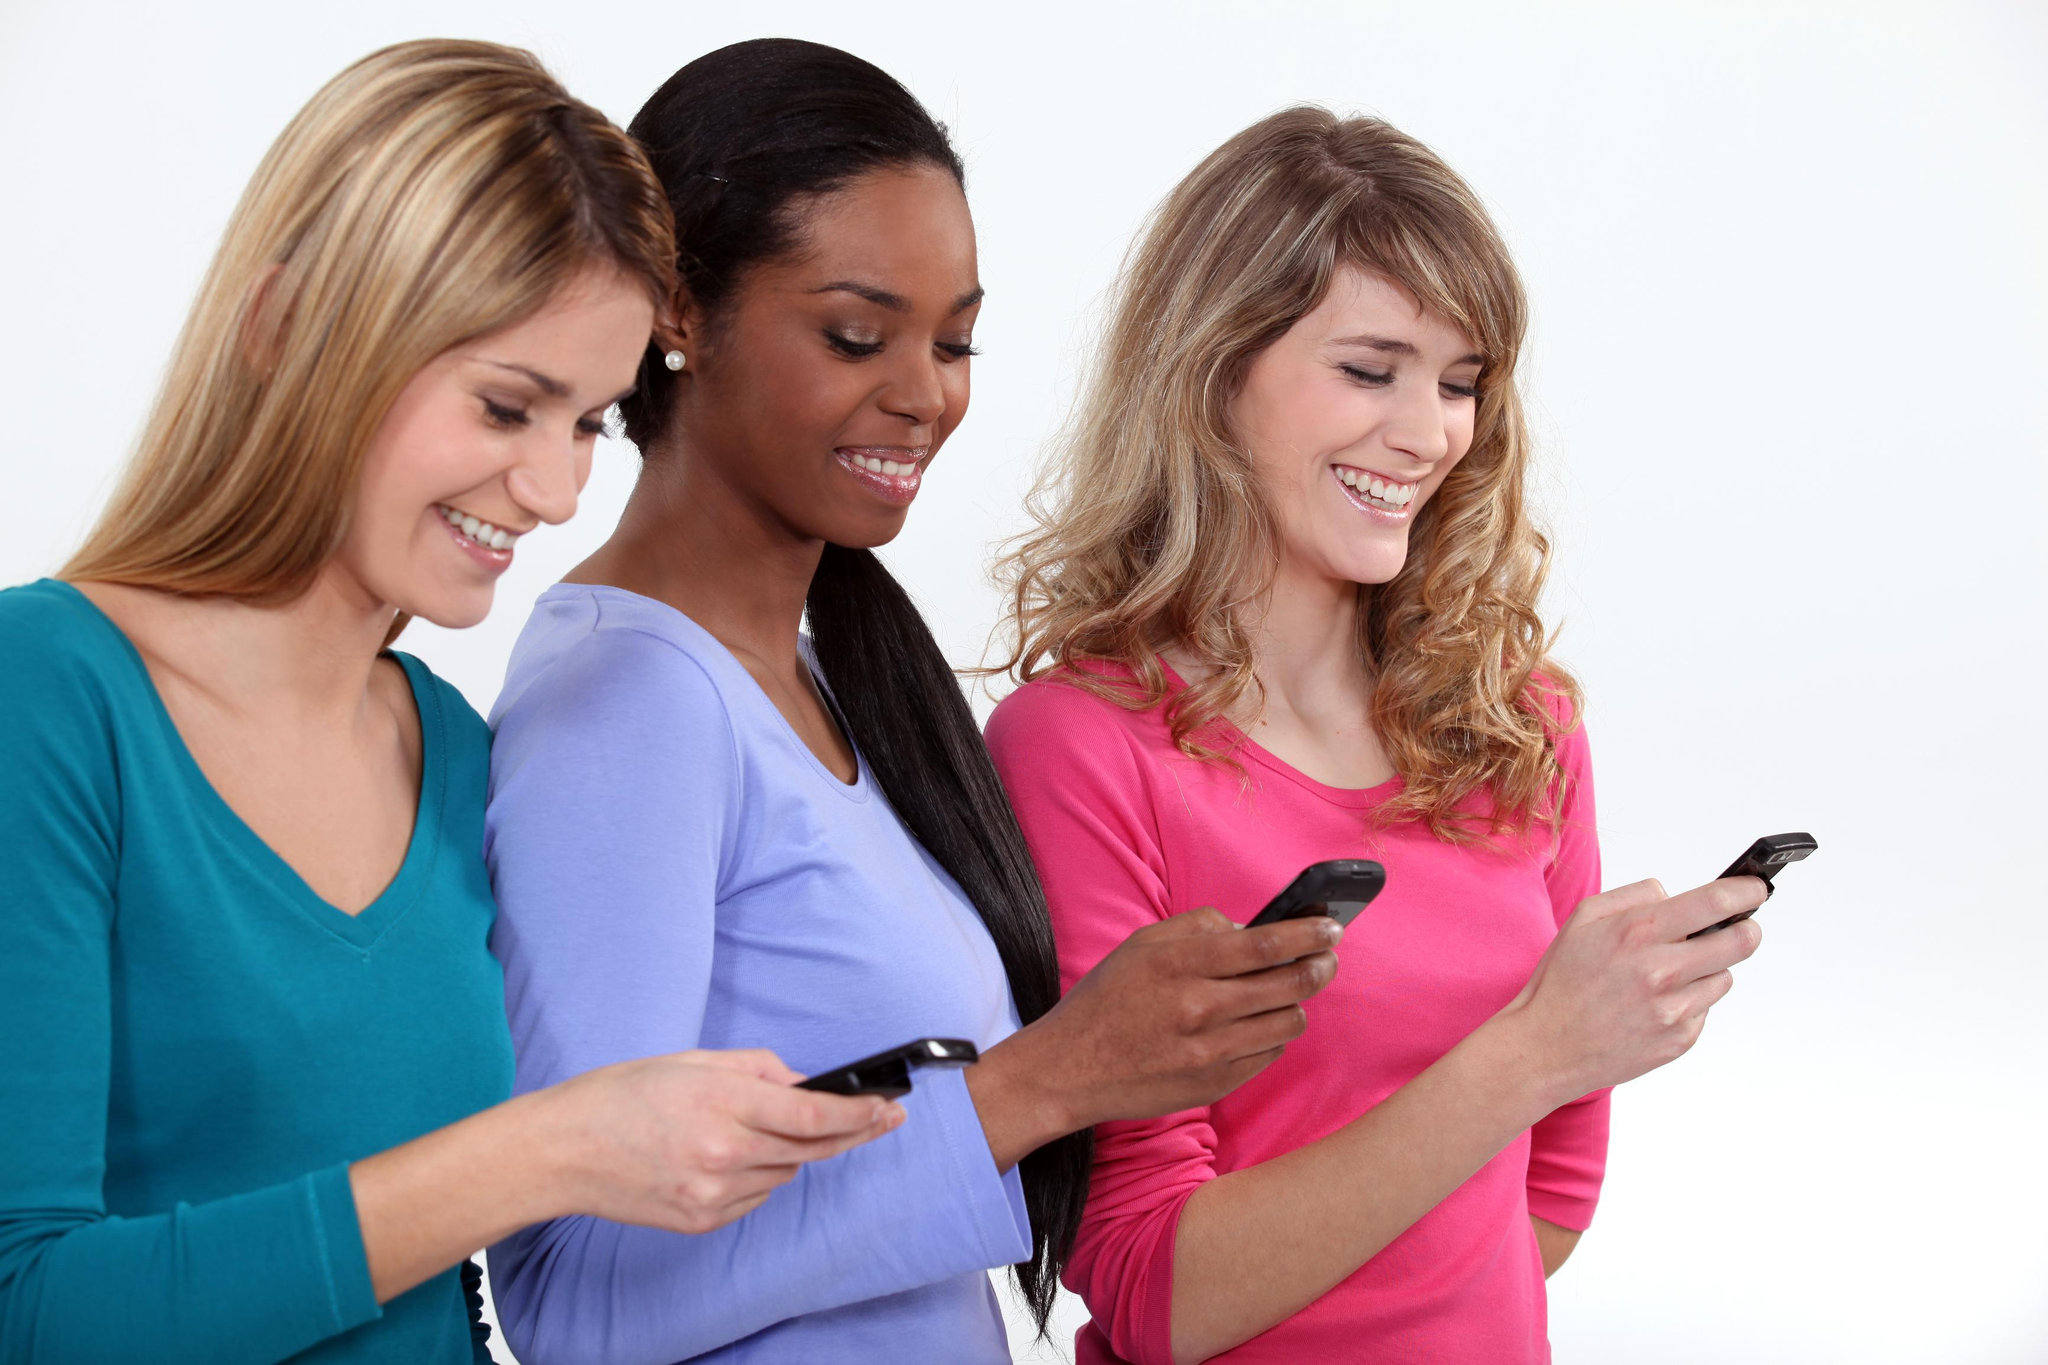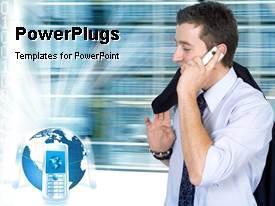The first image is the image on the left, the second image is the image on the right. Assess this claim about the two images: "The left and right image contains the same number of people on their phones.". Correct or not? Answer yes or no. No. The first image is the image on the left, the second image is the image on the right. For the images shown, is this caption "The left image contains a row of exactly three girls, and each girl is looking at a phone, but not every girl is holding a phone." true? Answer yes or no. No. 